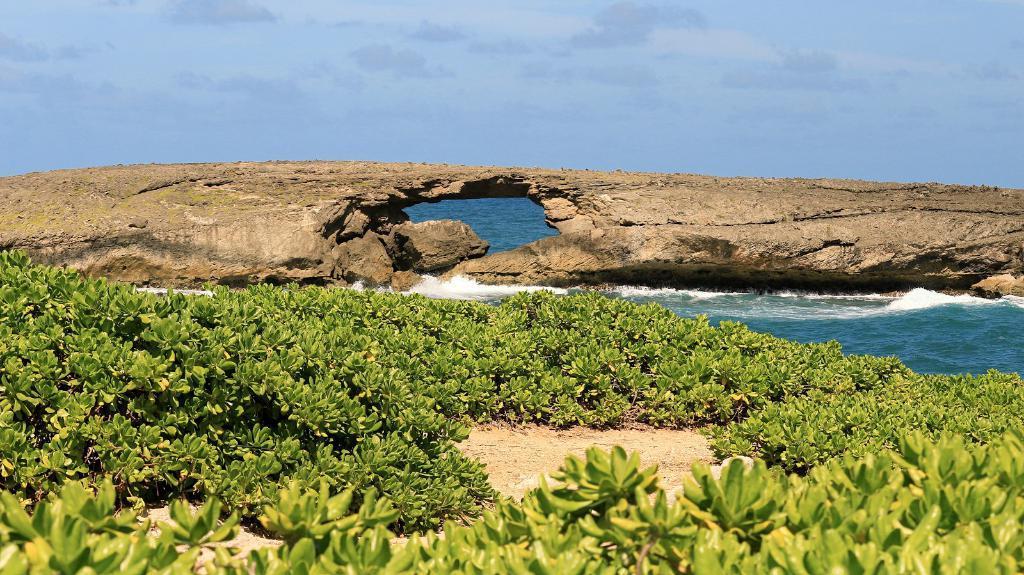How would you summarize this image in a sentence or two? At the bottom of the image on the ground there are small plants. Behind the ground there is water. There is a rock with hole in the water. At the top of the image there is sky. 